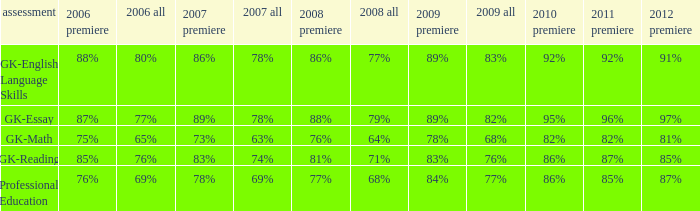What is the percentage for all 2008 when all in 2007 is 69%? 68%. 